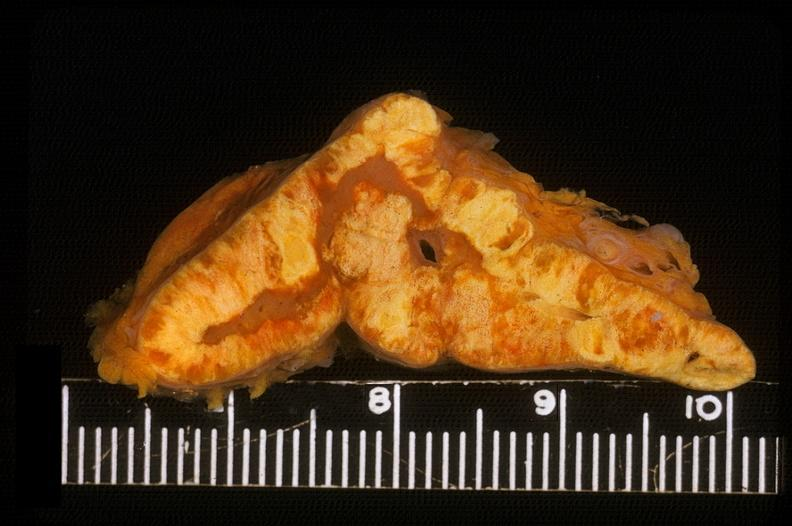what does this image show?
Answer the question using a single word or phrase. Adrenal 